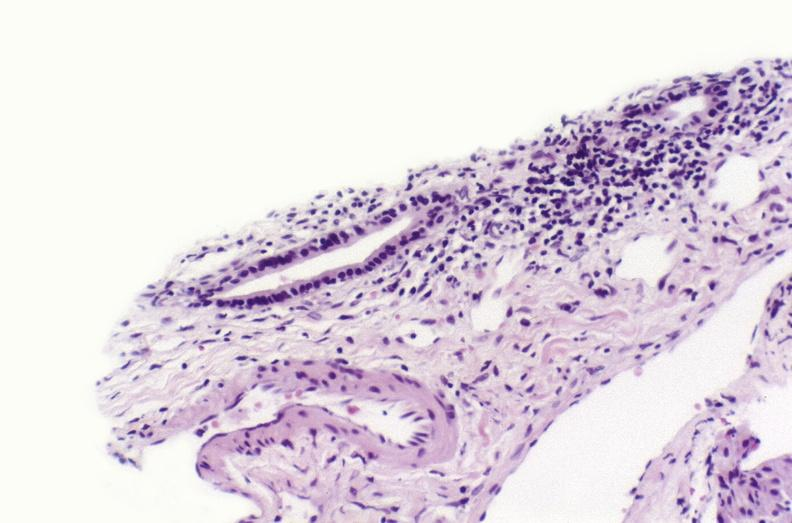what is present?
Answer the question using a single word or phrase. Liver 